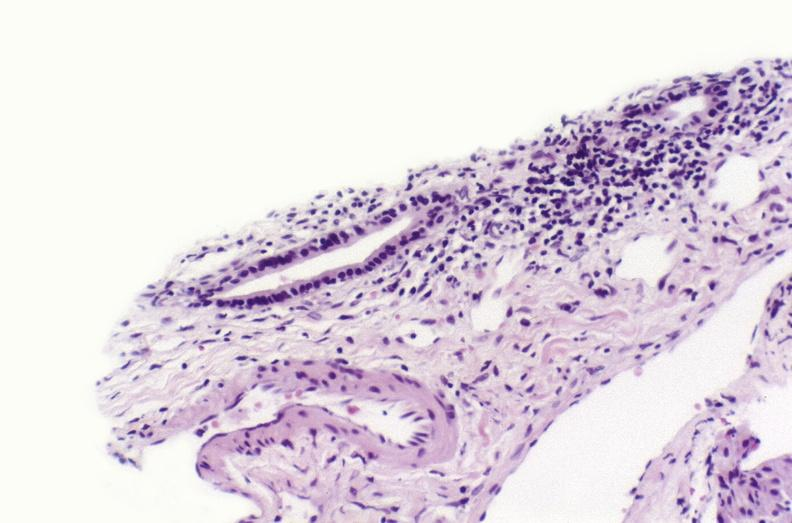what is present?
Answer the question using a single word or phrase. Liver 